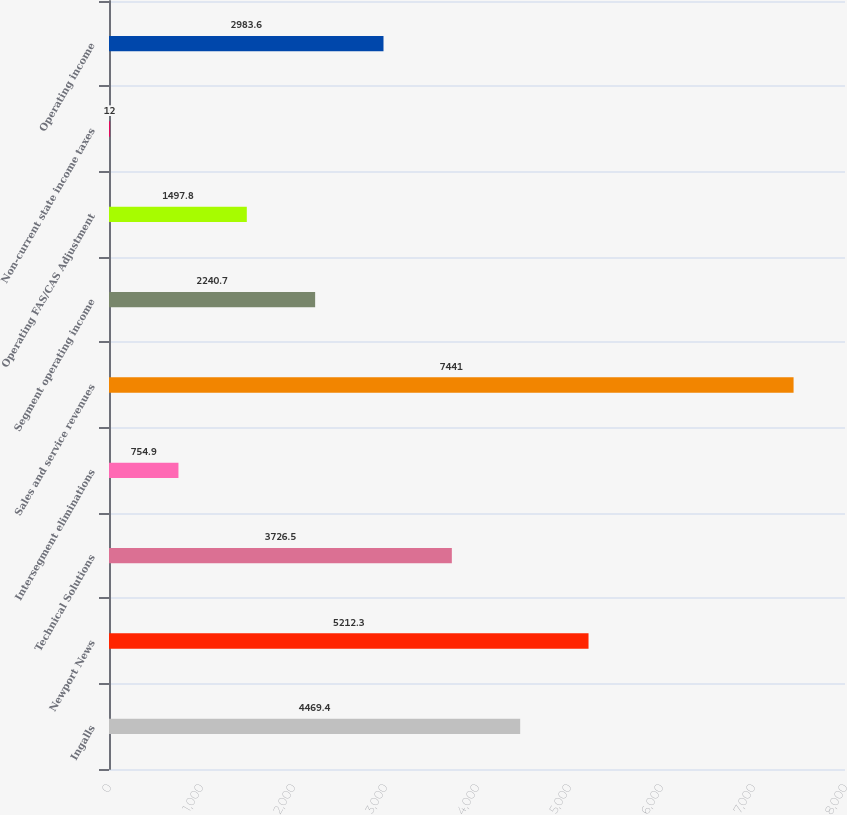Convert chart. <chart><loc_0><loc_0><loc_500><loc_500><bar_chart><fcel>Ingalls<fcel>Newport News<fcel>Technical Solutions<fcel>Intersegment eliminations<fcel>Sales and service revenues<fcel>Segment operating income<fcel>Operating FAS/CAS Adjustment<fcel>Non-current state income taxes<fcel>Operating income<nl><fcel>4469.4<fcel>5212.3<fcel>3726.5<fcel>754.9<fcel>7441<fcel>2240.7<fcel>1497.8<fcel>12<fcel>2983.6<nl></chart> 